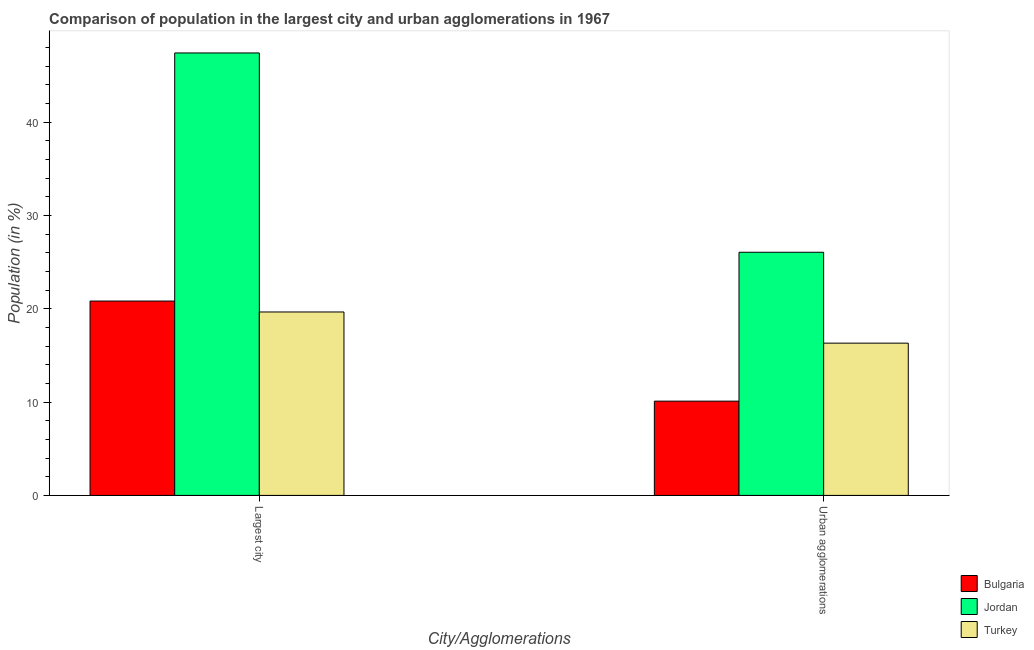How many groups of bars are there?
Provide a succinct answer. 2. Are the number of bars on each tick of the X-axis equal?
Your response must be concise. Yes. What is the label of the 1st group of bars from the left?
Provide a succinct answer. Largest city. What is the population in the largest city in Turkey?
Your answer should be compact. 19.65. Across all countries, what is the maximum population in urban agglomerations?
Keep it short and to the point. 26.05. Across all countries, what is the minimum population in urban agglomerations?
Offer a very short reply. 10.1. In which country was the population in urban agglomerations maximum?
Provide a succinct answer. Jordan. In which country was the population in urban agglomerations minimum?
Provide a short and direct response. Bulgaria. What is the total population in the largest city in the graph?
Offer a terse response. 87.88. What is the difference between the population in urban agglomerations in Turkey and that in Bulgaria?
Provide a succinct answer. 6.21. What is the difference between the population in urban agglomerations in Bulgaria and the population in the largest city in Turkey?
Provide a succinct answer. -9.55. What is the average population in urban agglomerations per country?
Offer a terse response. 17.49. What is the difference between the population in urban agglomerations and population in the largest city in Bulgaria?
Make the answer very short. -10.72. What is the ratio of the population in urban agglomerations in Jordan to that in Bulgaria?
Give a very brief answer. 2.58. Is the population in the largest city in Bulgaria less than that in Turkey?
Provide a succinct answer. No. In how many countries, is the population in the largest city greater than the average population in the largest city taken over all countries?
Provide a succinct answer. 1. What does the 2nd bar from the left in Largest city represents?
Provide a short and direct response. Jordan. What is the difference between two consecutive major ticks on the Y-axis?
Make the answer very short. 10. Does the graph contain grids?
Give a very brief answer. No. How many legend labels are there?
Ensure brevity in your answer.  3. What is the title of the graph?
Your answer should be compact. Comparison of population in the largest city and urban agglomerations in 1967. What is the label or title of the X-axis?
Provide a succinct answer. City/Agglomerations. What is the label or title of the Y-axis?
Your answer should be compact. Population (in %). What is the Population (in %) of Bulgaria in Largest city?
Your answer should be compact. 20.82. What is the Population (in %) of Jordan in Largest city?
Your response must be concise. 47.4. What is the Population (in %) of Turkey in Largest city?
Your answer should be compact. 19.65. What is the Population (in %) of Bulgaria in Urban agglomerations?
Provide a short and direct response. 10.1. What is the Population (in %) in Jordan in Urban agglomerations?
Keep it short and to the point. 26.05. What is the Population (in %) in Turkey in Urban agglomerations?
Offer a very short reply. 16.31. Across all City/Agglomerations, what is the maximum Population (in %) in Bulgaria?
Provide a succinct answer. 20.82. Across all City/Agglomerations, what is the maximum Population (in %) in Jordan?
Provide a short and direct response. 47.4. Across all City/Agglomerations, what is the maximum Population (in %) of Turkey?
Keep it short and to the point. 19.65. Across all City/Agglomerations, what is the minimum Population (in %) in Bulgaria?
Provide a succinct answer. 10.1. Across all City/Agglomerations, what is the minimum Population (in %) in Jordan?
Your response must be concise. 26.05. Across all City/Agglomerations, what is the minimum Population (in %) of Turkey?
Offer a terse response. 16.31. What is the total Population (in %) in Bulgaria in the graph?
Provide a succinct answer. 30.92. What is the total Population (in %) in Jordan in the graph?
Keep it short and to the point. 73.45. What is the total Population (in %) in Turkey in the graph?
Your answer should be very brief. 35.96. What is the difference between the Population (in %) in Bulgaria in Largest city and that in Urban agglomerations?
Offer a very short reply. 10.72. What is the difference between the Population (in %) in Jordan in Largest city and that in Urban agglomerations?
Provide a succinct answer. 21.35. What is the difference between the Population (in %) of Turkey in Largest city and that in Urban agglomerations?
Your answer should be compact. 3.34. What is the difference between the Population (in %) of Bulgaria in Largest city and the Population (in %) of Jordan in Urban agglomerations?
Provide a short and direct response. -5.23. What is the difference between the Population (in %) in Bulgaria in Largest city and the Population (in %) in Turkey in Urban agglomerations?
Your response must be concise. 4.51. What is the difference between the Population (in %) in Jordan in Largest city and the Population (in %) in Turkey in Urban agglomerations?
Ensure brevity in your answer.  31.09. What is the average Population (in %) of Bulgaria per City/Agglomerations?
Ensure brevity in your answer.  15.46. What is the average Population (in %) in Jordan per City/Agglomerations?
Your response must be concise. 36.73. What is the average Population (in %) in Turkey per City/Agglomerations?
Provide a short and direct response. 17.98. What is the difference between the Population (in %) of Bulgaria and Population (in %) of Jordan in Largest city?
Make the answer very short. -26.58. What is the difference between the Population (in %) in Bulgaria and Population (in %) in Turkey in Largest city?
Your answer should be very brief. 1.17. What is the difference between the Population (in %) of Jordan and Population (in %) of Turkey in Largest city?
Keep it short and to the point. 27.75. What is the difference between the Population (in %) of Bulgaria and Population (in %) of Jordan in Urban agglomerations?
Keep it short and to the point. -15.95. What is the difference between the Population (in %) of Bulgaria and Population (in %) of Turkey in Urban agglomerations?
Give a very brief answer. -6.21. What is the difference between the Population (in %) of Jordan and Population (in %) of Turkey in Urban agglomerations?
Your answer should be very brief. 9.74. What is the ratio of the Population (in %) of Bulgaria in Largest city to that in Urban agglomerations?
Provide a succinct answer. 2.06. What is the ratio of the Population (in %) in Jordan in Largest city to that in Urban agglomerations?
Make the answer very short. 1.82. What is the ratio of the Population (in %) in Turkey in Largest city to that in Urban agglomerations?
Provide a succinct answer. 1.2. What is the difference between the highest and the second highest Population (in %) in Bulgaria?
Your answer should be compact. 10.72. What is the difference between the highest and the second highest Population (in %) in Jordan?
Ensure brevity in your answer.  21.35. What is the difference between the highest and the second highest Population (in %) of Turkey?
Give a very brief answer. 3.34. What is the difference between the highest and the lowest Population (in %) of Bulgaria?
Make the answer very short. 10.72. What is the difference between the highest and the lowest Population (in %) of Jordan?
Your answer should be compact. 21.35. What is the difference between the highest and the lowest Population (in %) of Turkey?
Keep it short and to the point. 3.34. 